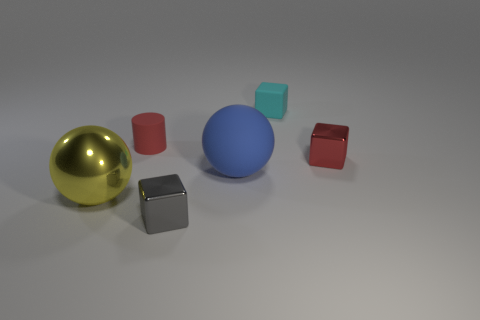How do the objects in the image relate to each other in terms of texture? The objects present a variety of textures. The golden sphere has a reflective glossy finish, which contrasts with the red and blue spheres that have matte textures. The cubes vary as well; the grey cube is matte, while the light blue and red cubes are somewhat translucent and partially reflect the environment. 